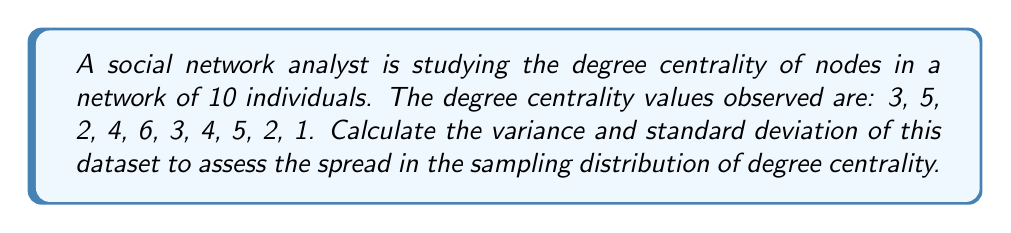Teach me how to tackle this problem. To calculate the variance and standard deviation, we'll follow these steps:

1. Calculate the mean ($\mu$) of the dataset:
   $$\mu = \frac{\sum_{i=1}^{n} x_i}{n} = \frac{3 + 5 + 2 + 4 + 6 + 3 + 4 + 5 + 2 + 1}{10} = \frac{35}{10} = 3.5$$

2. Calculate the squared differences from the mean:
   $$(3 - 3.5)^2 = 0.25$$
   $$(5 - 3.5)^2 = 2.25$$
   $$(2 - 3.5)^2 = 2.25$$
   $$(4 - 3.5)^2 = 0.25$$
   $$(6 - 3.5)^2 = 6.25$$
   $$(3 - 3.5)^2 = 0.25$$
   $$(4 - 3.5)^2 = 0.25$$
   $$(5 - 3.5)^2 = 2.25$$
   $$(2 - 3.5)^2 = 2.25$$
   $$(1 - 3.5)^2 = 6.25$$

3. Calculate the variance ($\sigma^2$):
   $$\sigma^2 = \frac{\sum_{i=1}^{n} (x_i - \mu)^2}{n} = \frac{0.25 + 2.25 + 2.25 + 0.25 + 6.25 + 0.25 + 0.25 + 2.25 + 2.25 + 6.25}{10} = \frac{22.5}{10} = 2.25$$

4. Calculate the standard deviation ($\sigma$):
   $$\sigma = \sqrt{\sigma^2} = \sqrt{2.25} = 1.5$$

The variance (2.25) and standard deviation (1.5) provide measures of the spread in the sampling distribution of degree centrality for this network.
Answer: Variance: 2.25, Standard Deviation: 1.5 